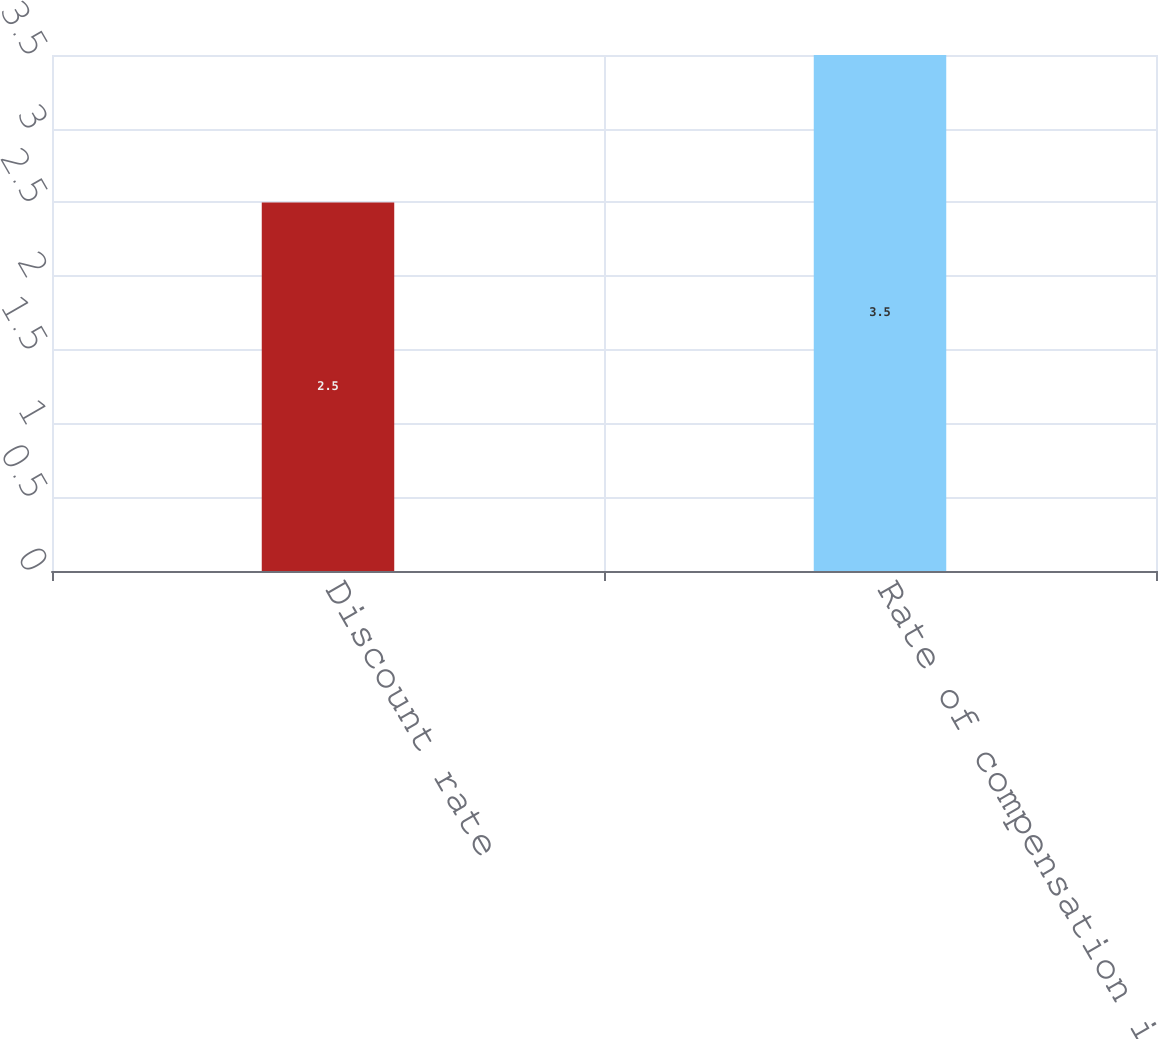<chart> <loc_0><loc_0><loc_500><loc_500><bar_chart><fcel>Discount rate<fcel>Rate of compensation increase<nl><fcel>2.5<fcel>3.5<nl></chart> 